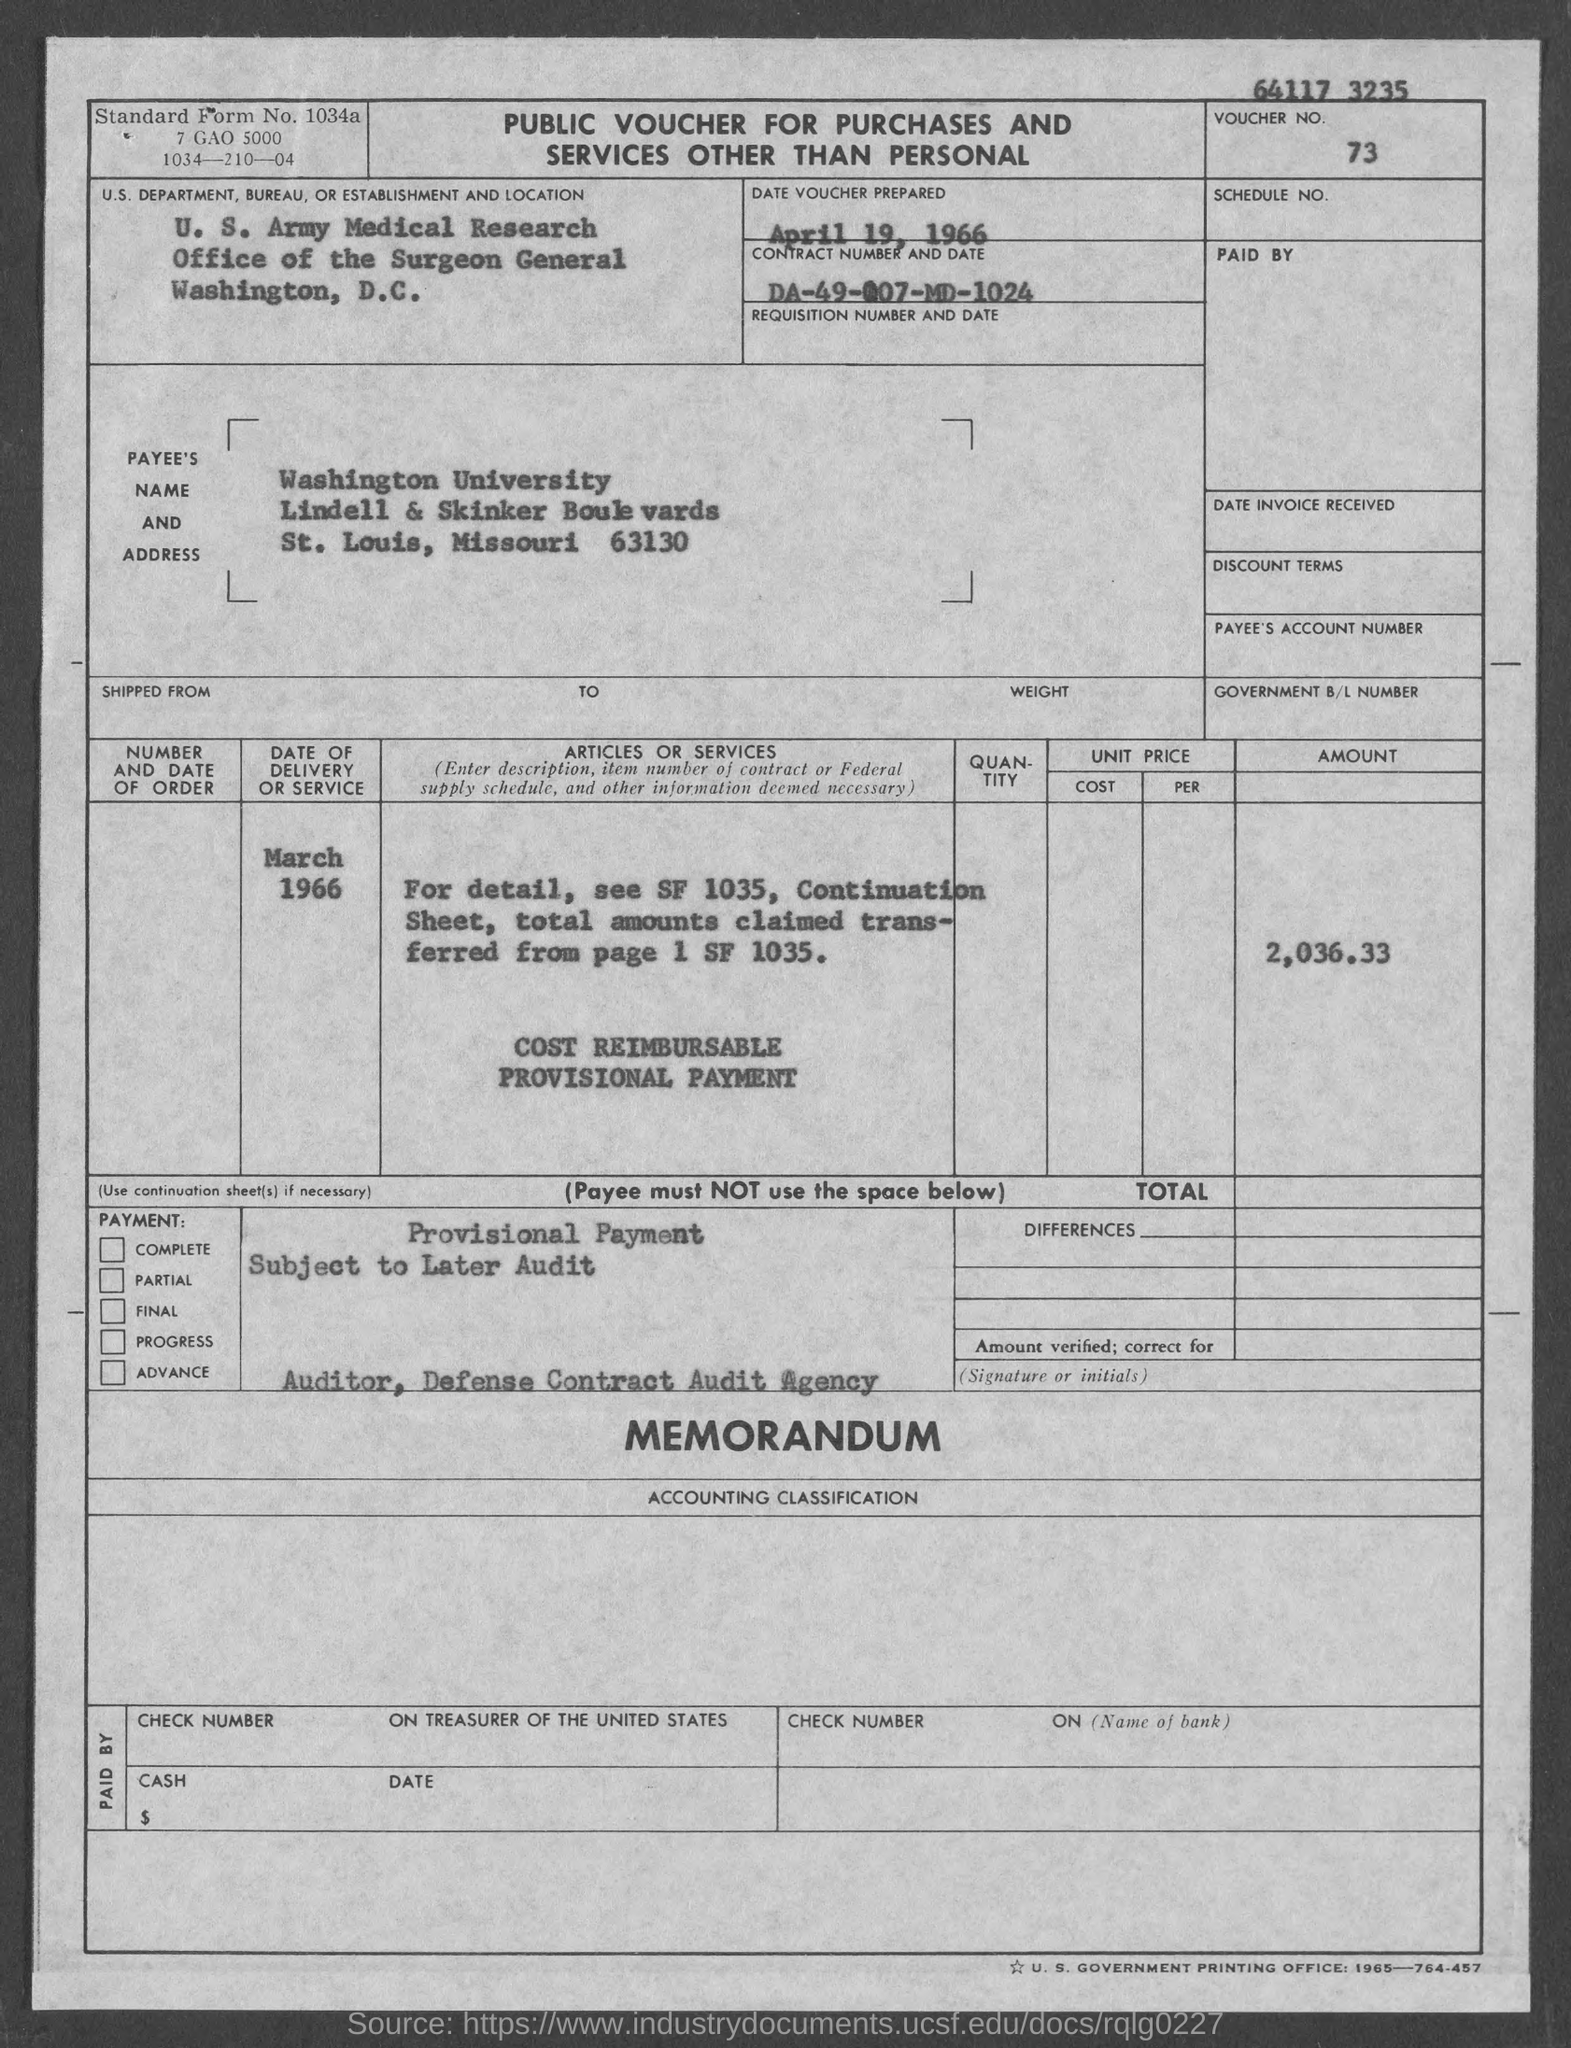What is the voucher no.?
Offer a very short reply. 73. What is the date of delivery or service ?
Make the answer very short. March 1966. What is the contract number ?
Your response must be concise. DA-49-007-MD-1024. 